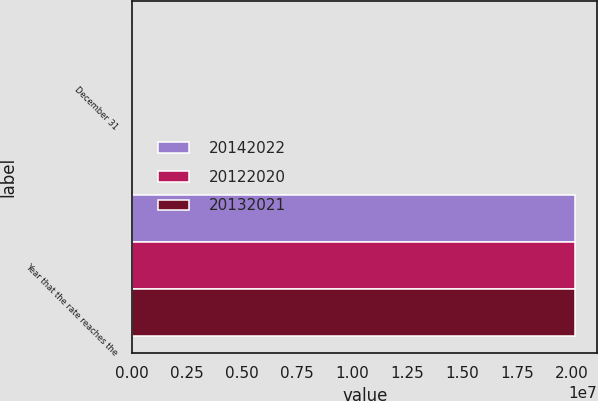Convert chart. <chart><loc_0><loc_0><loc_500><loc_500><stacked_bar_chart><ecel><fcel>December 31<fcel>Year that the rate reaches the<nl><fcel>2.0142e+07<fcel>2013<fcel>2.0142e+07<nl><fcel>2.0122e+07<fcel>2012<fcel>2.0132e+07<nl><fcel>2.0132e+07<fcel>2011<fcel>2.0122e+07<nl></chart> 